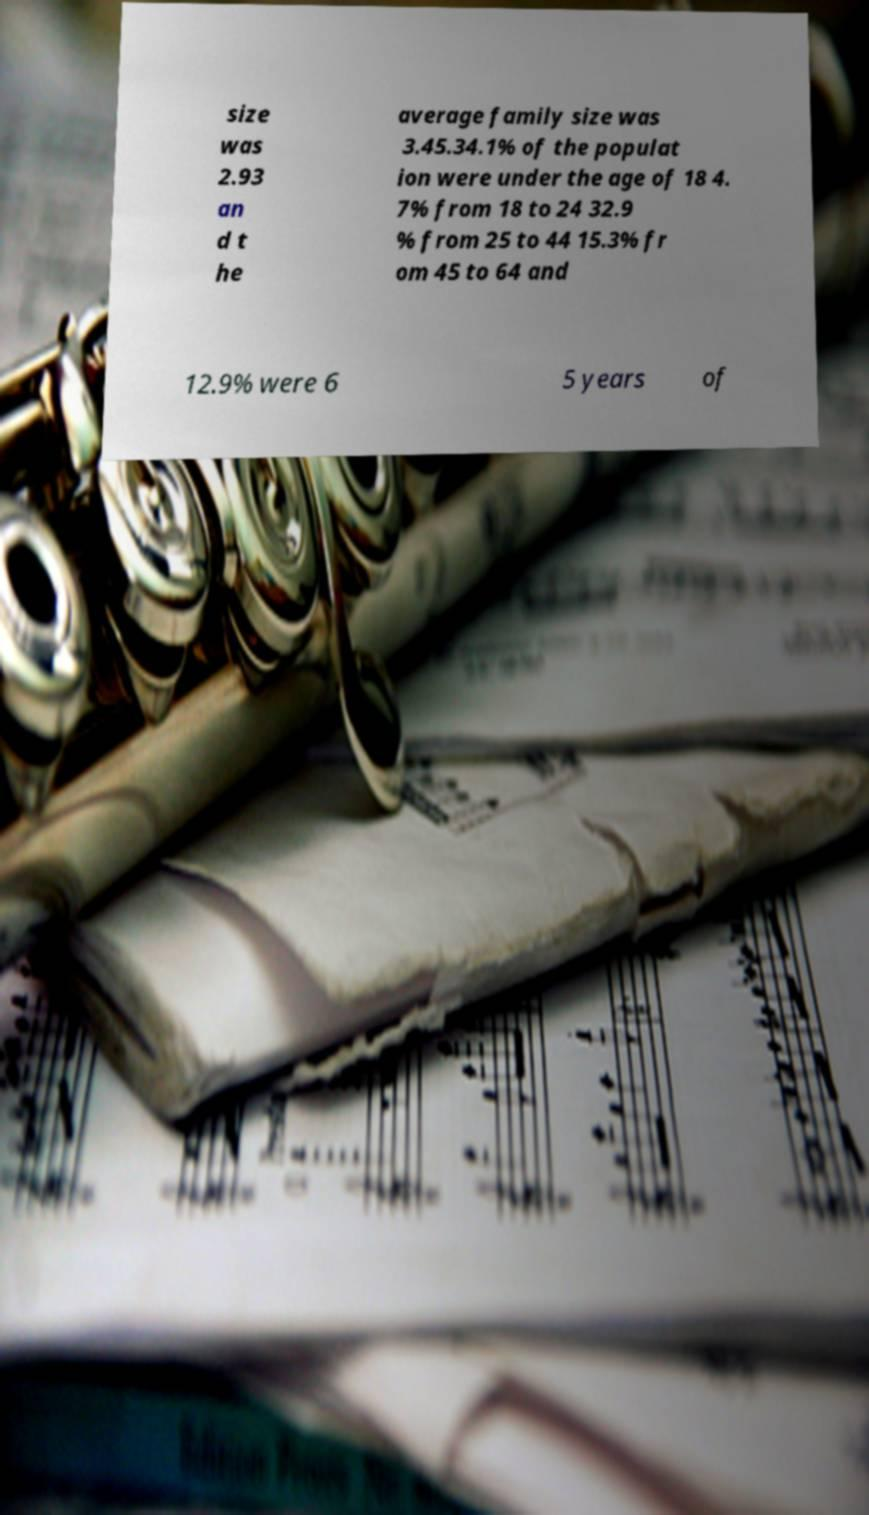Can you read and provide the text displayed in the image?This photo seems to have some interesting text. Can you extract and type it out for me? size was 2.93 an d t he average family size was 3.45.34.1% of the populat ion were under the age of 18 4. 7% from 18 to 24 32.9 % from 25 to 44 15.3% fr om 45 to 64 and 12.9% were 6 5 years of 